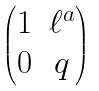Convert formula to latex. <formula><loc_0><loc_0><loc_500><loc_500>\begin{pmatrix} 1 & \ell ^ { a } \\ 0 & q \end{pmatrix}</formula> 